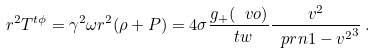<formula> <loc_0><loc_0><loc_500><loc_500>r ^ { 2 } T ^ { t \phi } = \gamma ^ { 2 } \omega r ^ { 2 } ( \rho + P ) = 4 \sigma \frac { g _ { + } ( \ v o ) } { \ t w } \frac { v ^ { 2 } } { \ p r n { 1 - v ^ { 2 } } ^ { 3 } } \, .</formula> 